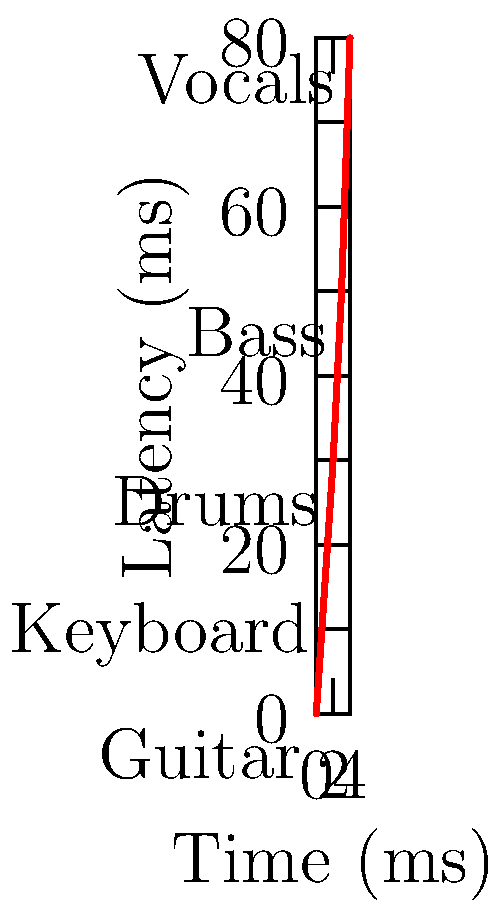In a virtual band setup, various instruments are connected with different latencies. Given the graph showing the latency for each instrument, what is the total end-to-end latency for a signal passing through all instruments in the order: Guitar → Keyboard → Drums → Bass → Vocals? To calculate the total end-to-end latency, we need to sum up the individual latencies for each instrument in the given order:

1. Guitar: 0 ms (starting point)
2. Keyboard: 15 ms
3. Drums: 30 ms
4. Bass: 50 ms
5. Vocals: 80 ms

The total latency is the sum of these values:

$$ \text{Total Latency} = 0 + 15 + 30 + 50 + 80 = 175 \text{ ms} $$

This represents the time it takes for a signal to pass through all instruments in the specified order.
Answer: 175 ms 